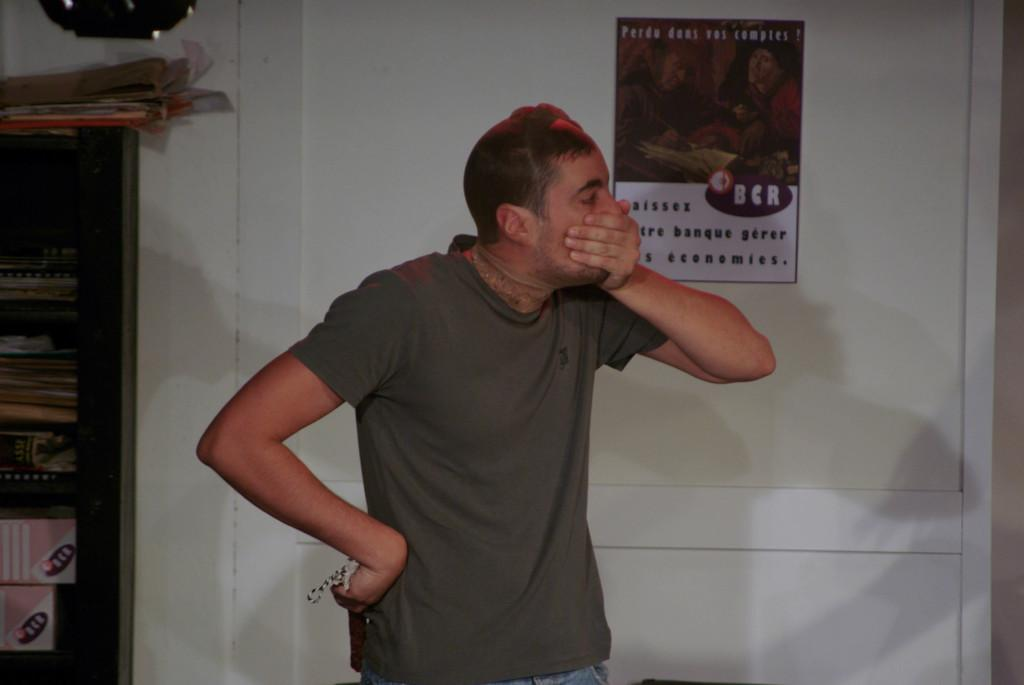Provide a one-sentence caption for the provided image. The young man clutching his face stands in front of a door that has a poster with French text. 